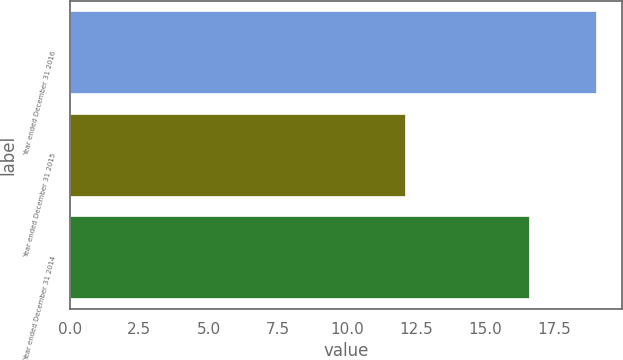Convert chart to OTSL. <chart><loc_0><loc_0><loc_500><loc_500><bar_chart><fcel>Year ended December 31 2016<fcel>Year ended December 31 2015<fcel>Year ended December 31 2014<nl><fcel>19<fcel>12.1<fcel>16.6<nl></chart> 